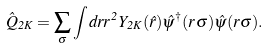Convert formula to latex. <formula><loc_0><loc_0><loc_500><loc_500>\hat { Q } _ { 2 K } = \sum _ { \sigma } \int d r r ^ { 2 } Y _ { 2 K } ( \hat { r } ) \hat { \psi } ^ { \dagger } ( r \sigma ) \hat { \psi } ( r \sigma ) .</formula> 